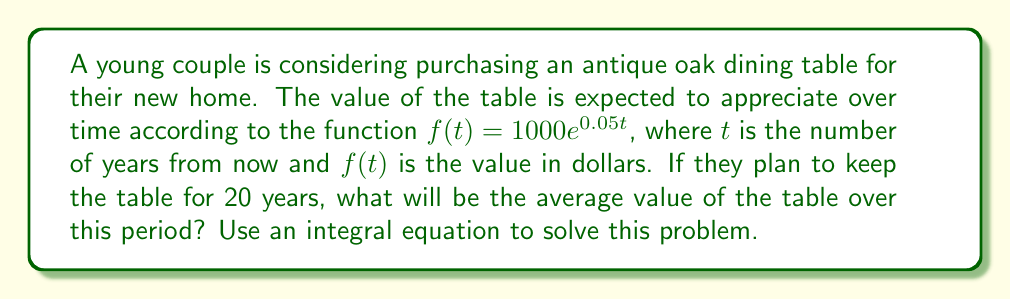Solve this math problem. To find the average value of the table over 20 years, we need to:

1. Set up the integral equation for the average value:
   $$\text{Average Value} = \frac{1}{b-a} \int_{a}^{b} f(t) dt$$
   where $a = 0$ and $b = 20$ (years)

2. Substitute the given function and limits:
   $$\text{Average Value} = \frac{1}{20-0} \int_{0}^{20} 1000e^{0.05t} dt$$

3. Simplify:
   $$\text{Average Value} = \frac{1}{20} \int_{0}^{20} 1000e^{0.05t} dt$$

4. Evaluate the integral:
   $$\begin{align}
   \text{Average Value} &= \frac{1}{20} \cdot 1000 \cdot \frac{1}{0.05} [e^{0.05t}]_{0}^{20} \\
   &= \frac{1000}{20 \cdot 0.05} (e^{1} - 1) \\
   &= 1000 \cdot (e^{1} - 1)
   \end{align}$$

5. Calculate the final value:
   $$\text{Average Value} \approx 1718.28$$
Answer: $1718.28 